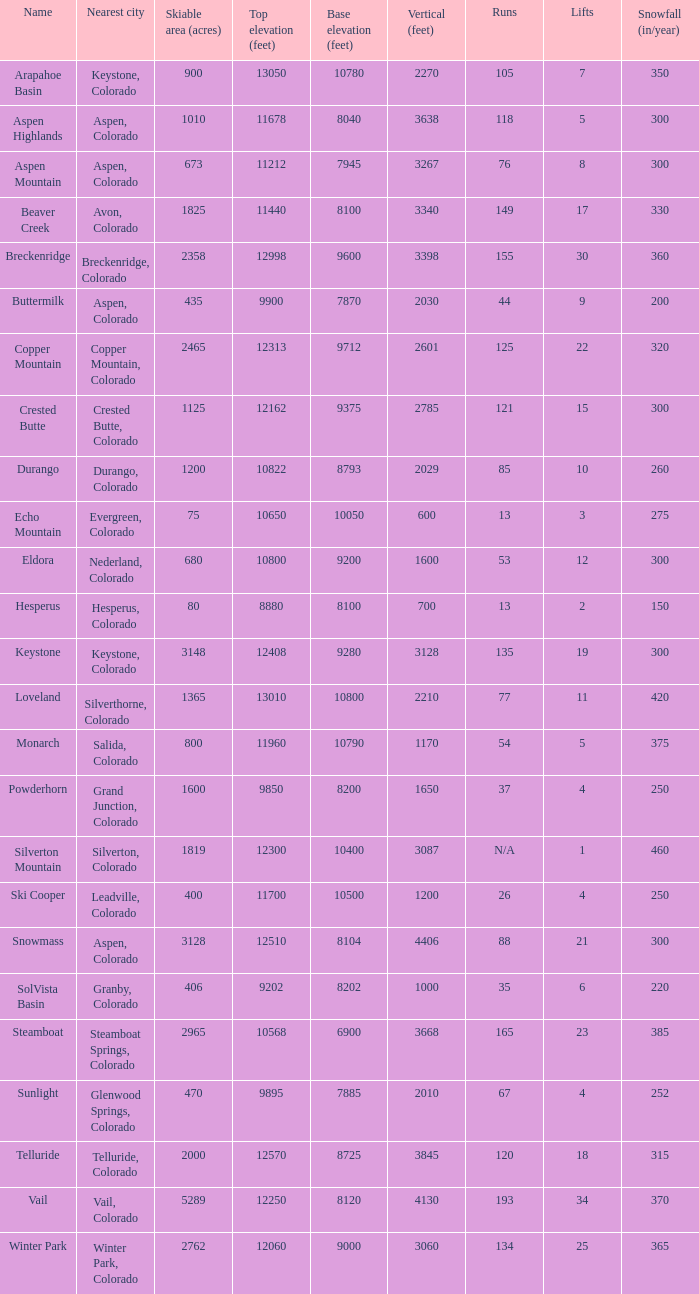Which ski resort features 30 ski lifts? Breckenridge. 